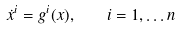<formula> <loc_0><loc_0><loc_500><loc_500>\dot { x } ^ { i } = g ^ { i } ( x ) , \quad i = 1 , \dots n</formula> 